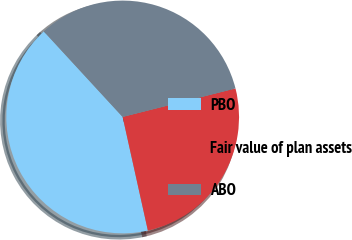Convert chart to OTSL. <chart><loc_0><loc_0><loc_500><loc_500><pie_chart><fcel>PBO<fcel>Fair value of plan assets<fcel>ABO<nl><fcel>41.63%<fcel>25.46%<fcel>32.92%<nl></chart> 